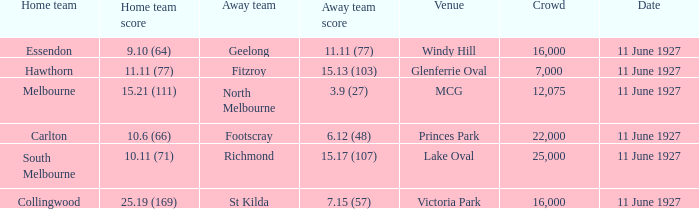How many people were in the crowd when Essendon was the home team? 1.0. 